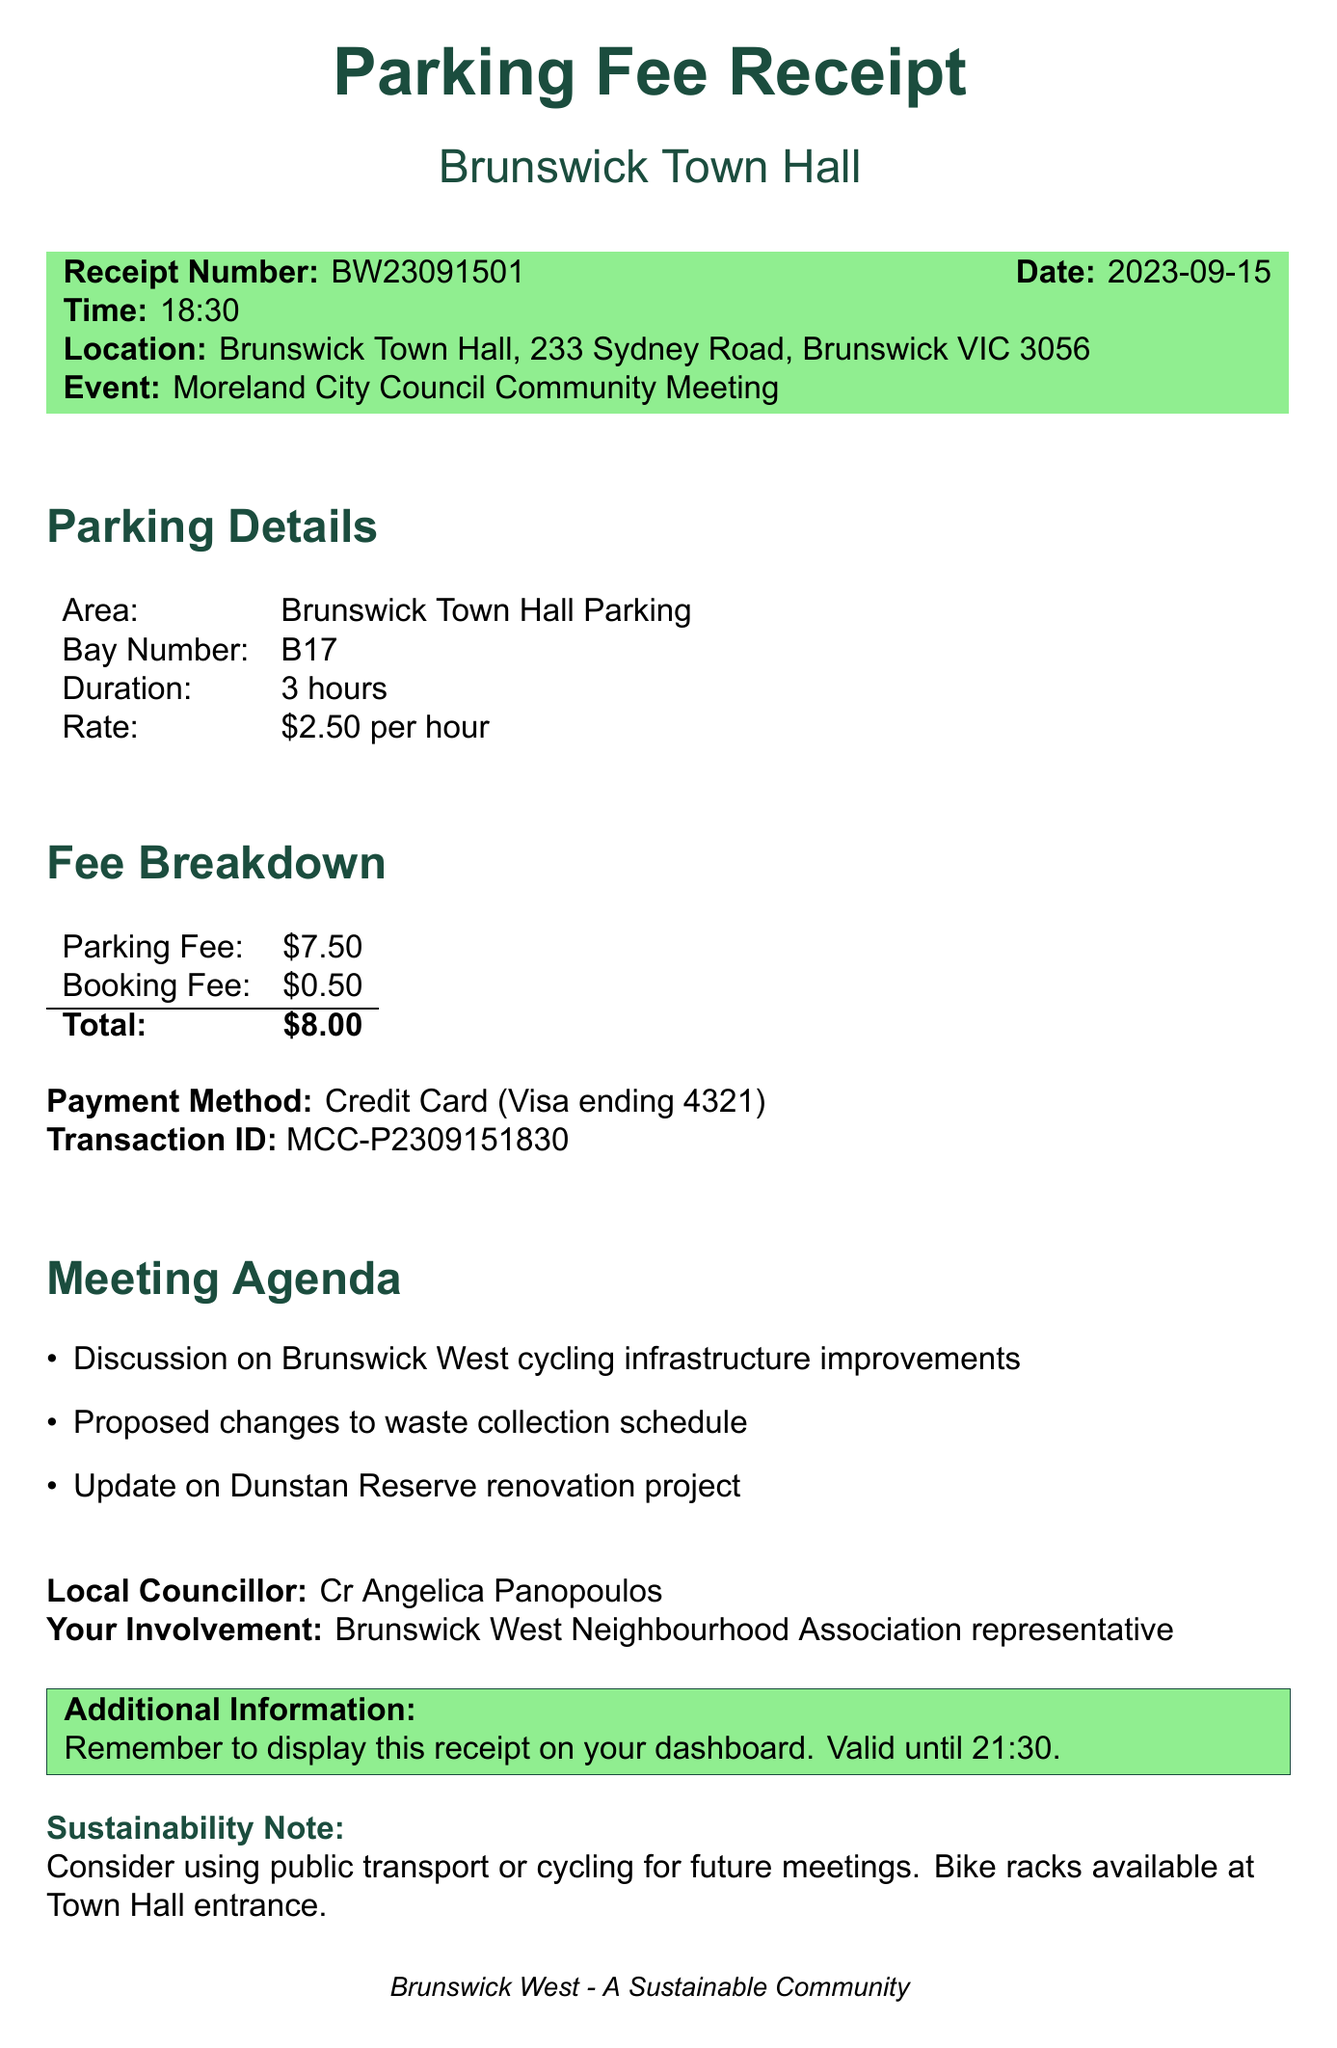What is the receipt number? The receipt number is explicitly stated in the document as a specific identifier for the transaction.
Answer: BW23091501 When was the parking fee paid? The document lists the date of the receipt, which signifies when the payment was made.
Answer: 2023-09-15 What is the total parking fee? The total fee is provided in the fee breakdown section, showing the complete cost incurred.
Answer: $8.00 How long was the parking duration? The duration of parking is specified in the parking details section of the receipt.
Answer: 3 hours Who is the local councillor? The name of the local councillor is mentioned in the document, indicating the elected official for the area.
Answer: Cr Angelica Panopoulos What type of event was attended? The type of event is highlighted clearly in the document, indicating what the parking fee was associated with.
Answer: Moreland City Council Community Meeting What is the parking rate per hour? The document specifies the rate charged per hour for parking, which is a key detail in the receipt.
Answer: $2.50 per hour What payment method was used? The payment method is detailed in the receipt, providing insight into how the transaction was completed.
Answer: Credit Card (Visa ending 4321) What is the council contact email? The contact email for the council is provided in the document for inquiries or follow-up.
Answer: info@moreland.vic.gov.au 